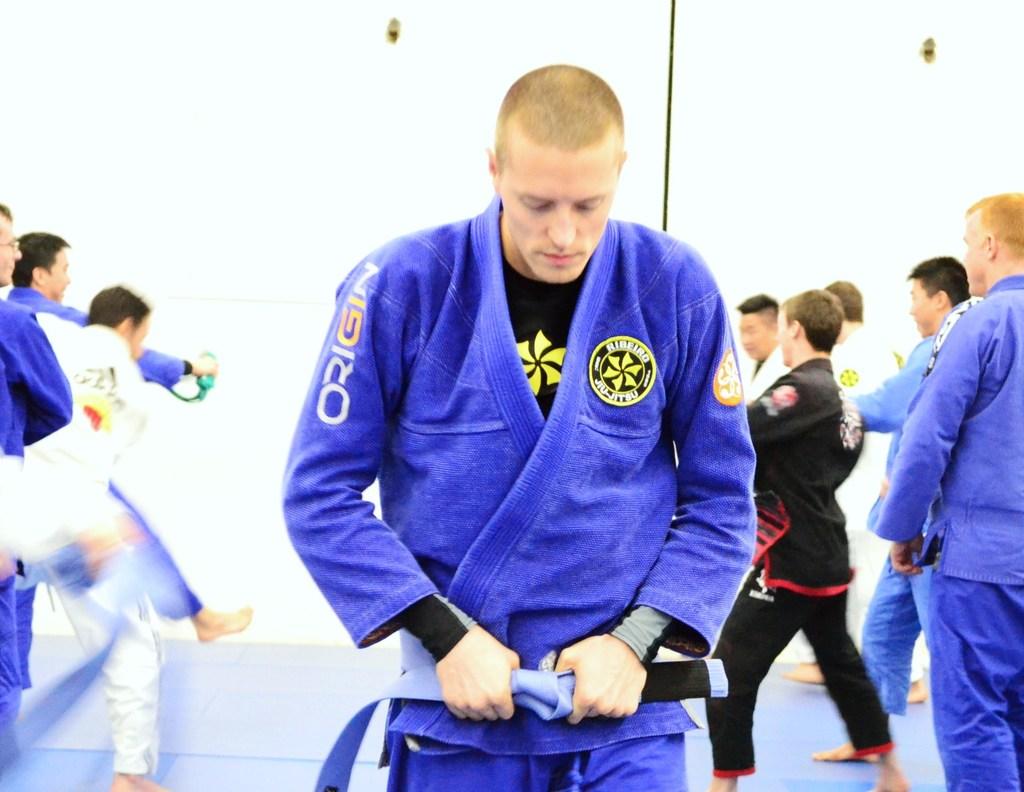What type of martial arts does this man do?
Provide a succinct answer. Jiu-jitsu. 